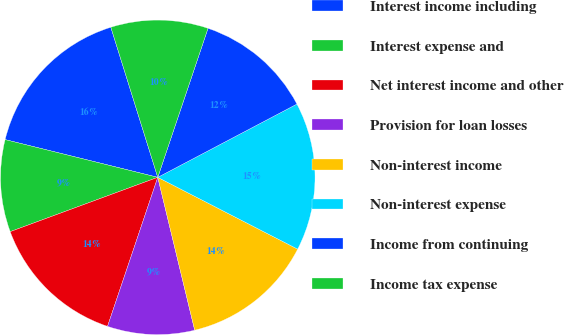Convert chart to OTSL. <chart><loc_0><loc_0><loc_500><loc_500><pie_chart><fcel>Interest income including<fcel>Interest expense and<fcel>Net interest income and other<fcel>Provision for loan losses<fcel>Non-interest income<fcel>Non-interest expense<fcel>Income from continuing<fcel>Income tax expense<nl><fcel>16.32%<fcel>9.47%<fcel>14.21%<fcel>8.95%<fcel>13.68%<fcel>15.26%<fcel>12.11%<fcel>10.0%<nl></chart> 